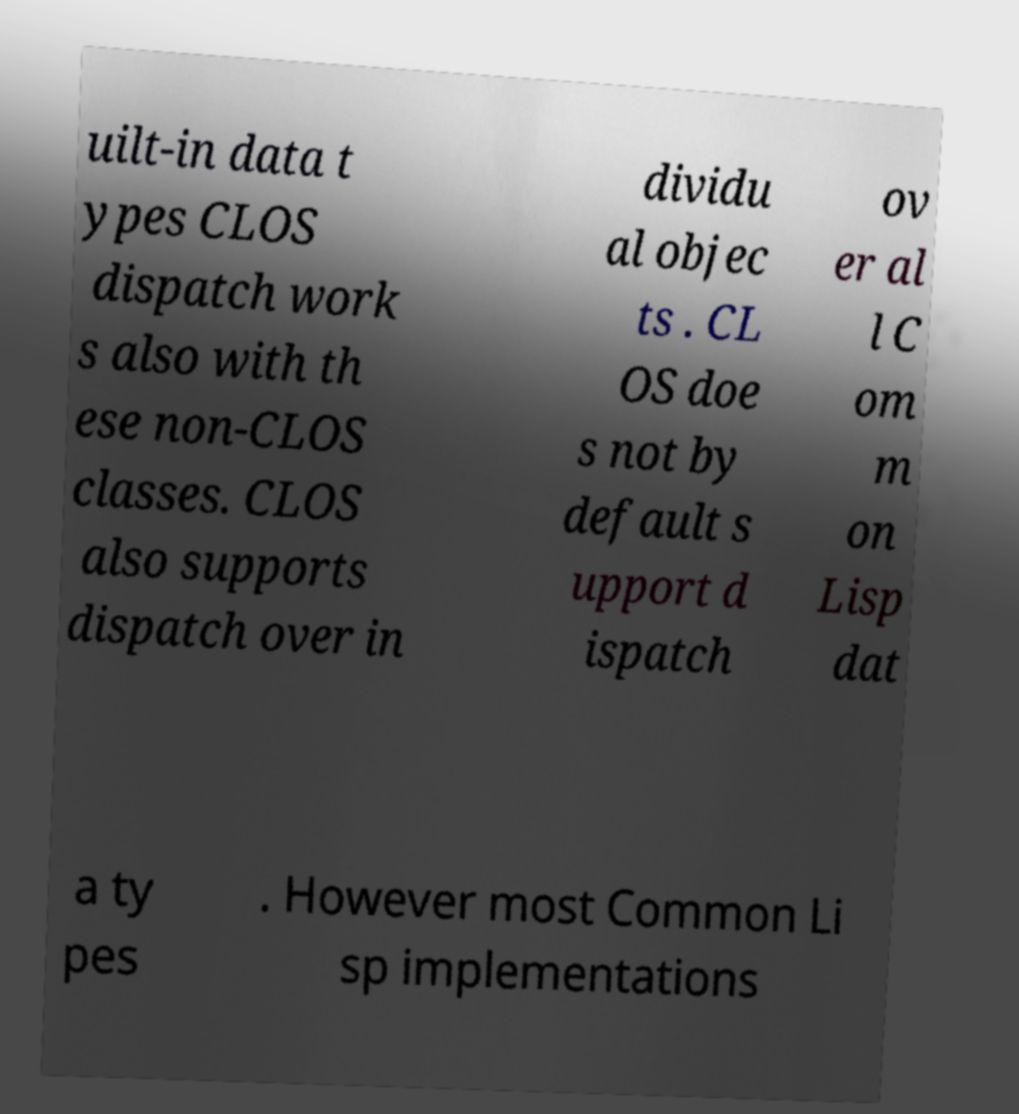What messages or text are displayed in this image? I need them in a readable, typed format. uilt-in data t ypes CLOS dispatch work s also with th ese non-CLOS classes. CLOS also supports dispatch over in dividu al objec ts . CL OS doe s not by default s upport d ispatch ov er al l C om m on Lisp dat a ty pes . However most Common Li sp implementations 